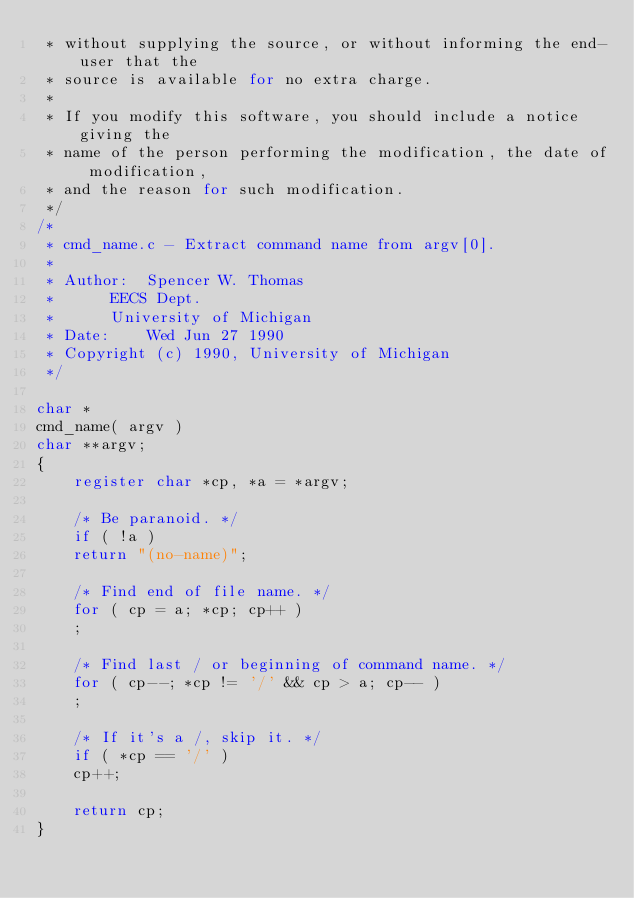Convert code to text. <code><loc_0><loc_0><loc_500><loc_500><_C_> * without supplying the source, or without informing the end-user that the 
 * source is available for no extra charge.
 *
 * If you modify this software, you should include a notice giving the
 * name of the person performing the modification, the date of modification,
 * and the reason for such modification.
 */
/* 
 * cmd_name.c - Extract command name from argv[0].
 * 
 * Author:	Spencer W. Thomas
 * 		EECS Dept.
 * 		University of Michigan
 * Date:	Wed Jun 27 1990
 * Copyright (c) 1990, University of Michigan
 */

char *
cmd_name( argv )
char **argv;
{
    register char *cp, *a = *argv;

    /* Be paranoid. */
    if ( !a )
	return "(no-name)";

    /* Find end of file name. */
    for ( cp = a; *cp; cp++ )
	;

    /* Find last / or beginning of command name. */
    for ( cp--; *cp != '/' && cp > a; cp-- )
	;
    
    /* If it's a /, skip it. */
    if ( *cp == '/' )
	cp++;

    return cp;
}
</code> 